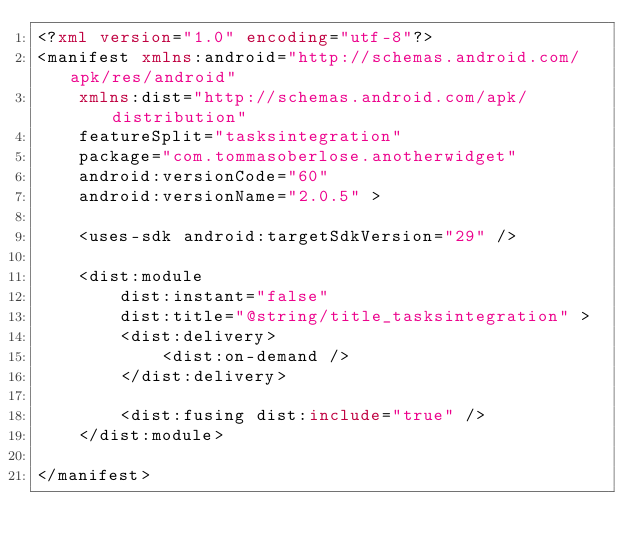Convert code to text. <code><loc_0><loc_0><loc_500><loc_500><_XML_><?xml version="1.0" encoding="utf-8"?>
<manifest xmlns:android="http://schemas.android.com/apk/res/android"
    xmlns:dist="http://schemas.android.com/apk/distribution"
    featureSplit="tasksintegration"
    package="com.tommasoberlose.anotherwidget"
    android:versionCode="60"
    android:versionName="2.0.5" >

    <uses-sdk android:targetSdkVersion="29" />

    <dist:module
        dist:instant="false"
        dist:title="@string/title_tasksintegration" >
        <dist:delivery>
            <dist:on-demand />
        </dist:delivery>

        <dist:fusing dist:include="true" />
    </dist:module>

</manifest></code> 